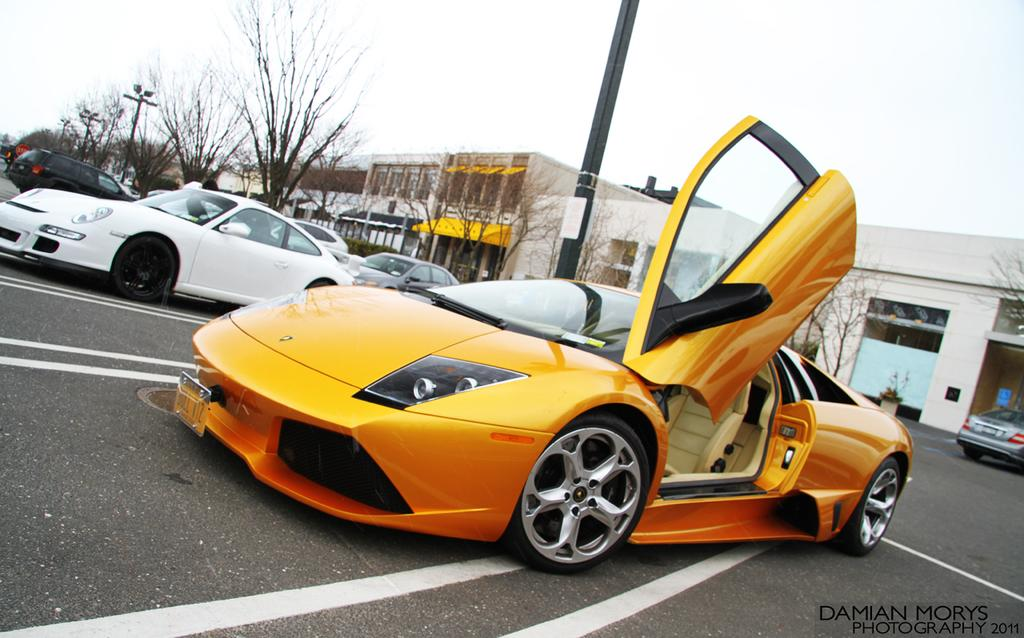What type of car is in the foreground of the image? There is an orange car in the foreground of the image. What is the state of the car's door in the image? The car has one door open. Where is the car located in the image? The car is on the road. What can be seen in the background of the image? There are cars, poles, trees, buildings, and the sky visible in the background of the image. What brand of toothpaste is the boy using in the image? There is no boy or toothpaste present in the image. What is the rate of the car's speed in the image? The image does not provide information about the car's speed, so it cannot be determined. 